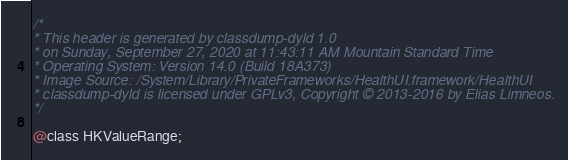<code> <loc_0><loc_0><loc_500><loc_500><_C_>/*
* This header is generated by classdump-dyld 1.0
* on Sunday, September 27, 2020 at 11:43:11 AM Mountain Standard Time
* Operating System: Version 14.0 (Build 18A373)
* Image Source: /System/Library/PrivateFrameworks/HealthUI.framework/HealthUI
* classdump-dyld is licensed under GPLv3, Copyright © 2013-2016 by Elias Limneos.
*/

@class HKValueRange;

</code> 